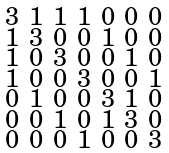Convert formula to latex. <formula><loc_0><loc_0><loc_500><loc_500>\begin{smallmatrix} 3 & 1 & 1 & 1 & 0 & 0 & 0 \\ 1 & 3 & 0 & 0 & 1 & 0 & 0 \\ 1 & 0 & 3 & 0 & 0 & 1 & 0 \\ 1 & 0 & 0 & 3 & 0 & 0 & 1 \\ 0 & 1 & 0 & 0 & 3 & 1 & 0 \\ 0 & 0 & 1 & 0 & 1 & 3 & 0 \\ 0 & 0 & 0 & 1 & 0 & 0 & 3 \end{smallmatrix}</formula> 